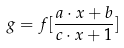Convert formula to latex. <formula><loc_0><loc_0><loc_500><loc_500>g = f [ \frac { a \cdot x + b } { c \cdot x + 1 } ]</formula> 